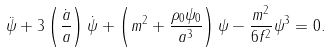Convert formula to latex. <formula><loc_0><loc_0><loc_500><loc_500>\ddot { \psi } + 3 \left ( \frac { \dot { a } } { a } \right ) \dot { \psi } + \left ( m ^ { 2 } + \frac { \rho _ { 0 } \psi _ { 0 } } { a ^ { 3 } } \right ) \psi - \frac { m ^ { 2 } } { 6 f ^ { 2 } } \psi ^ { 3 } = 0 .</formula> 